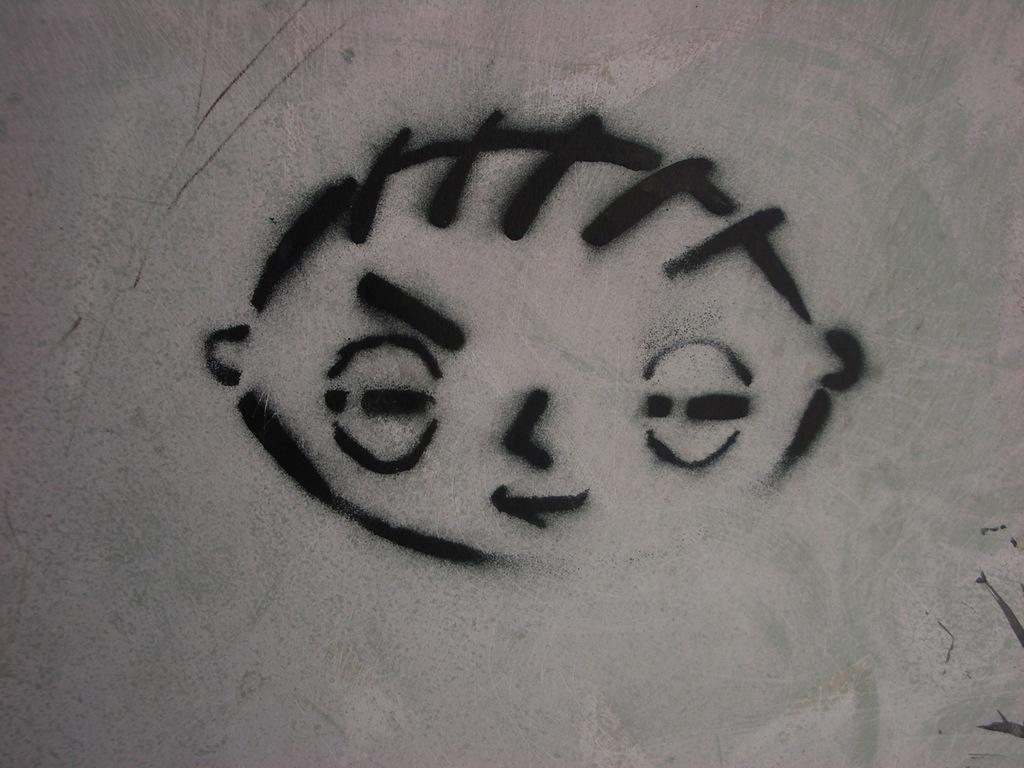How would you summarize this image in a sentence or two? This image looks like, it is a painting on the wall. This looks like a face. 